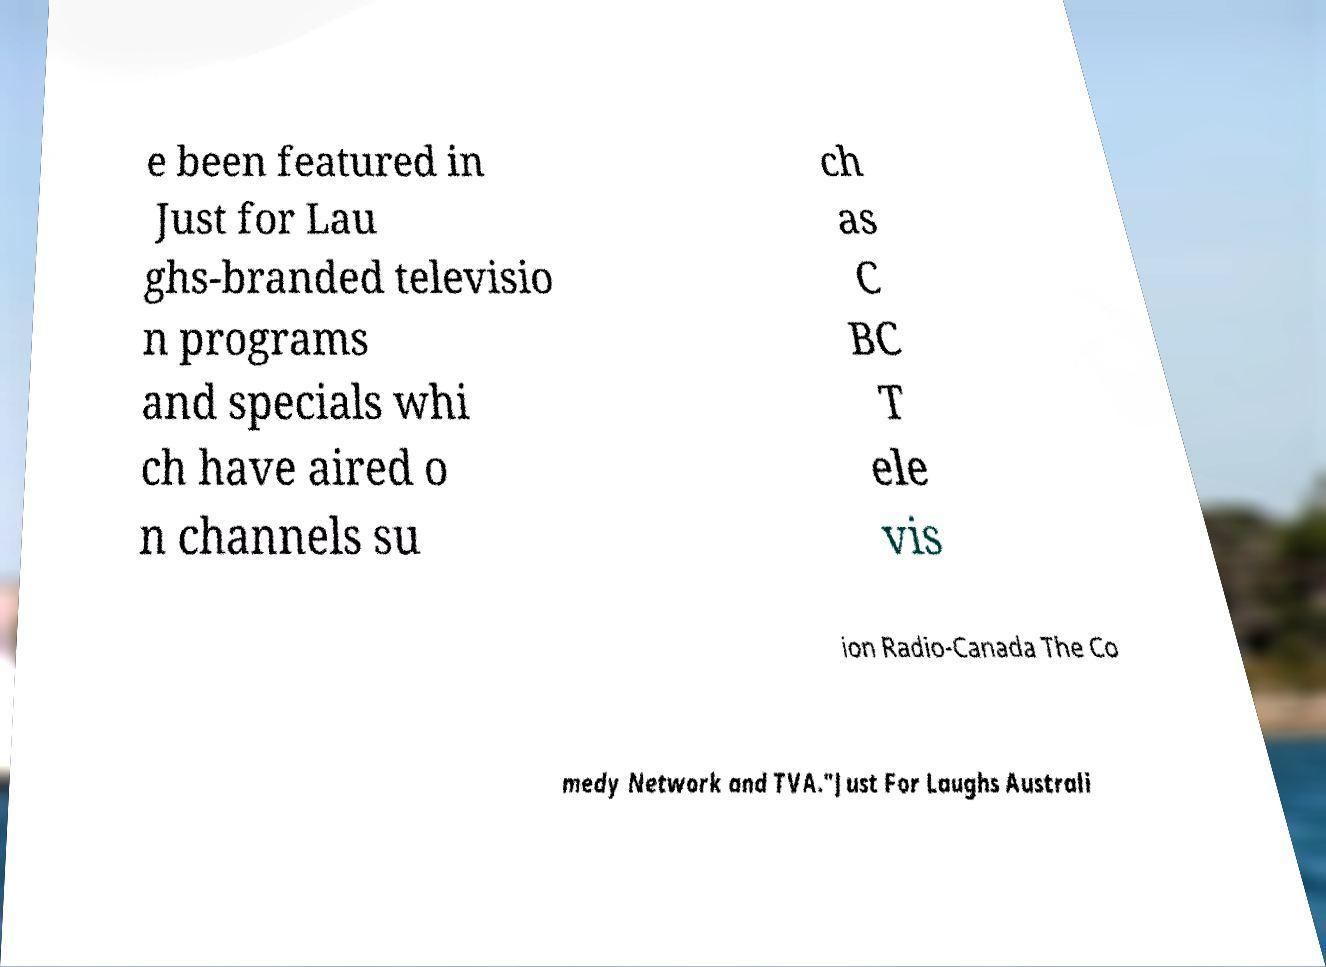For documentation purposes, I need the text within this image transcribed. Could you provide that? e been featured in Just for Lau ghs-branded televisio n programs and specials whi ch have aired o n channels su ch as C BC T ele vis ion Radio-Canada The Co medy Network and TVA."Just For Laughs Australi 